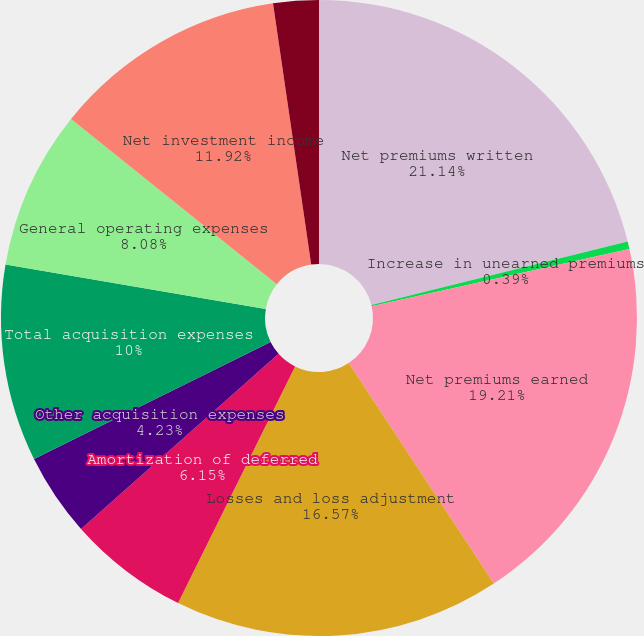Convert chart. <chart><loc_0><loc_0><loc_500><loc_500><pie_chart><fcel>Net premiums written<fcel>Increase in unearned premiums<fcel>Net premiums earned<fcel>Losses and loss adjustment<fcel>Amortization of deferred<fcel>Other acquisition expenses<fcel>Total acquisition expenses<fcel>General operating expenses<fcel>Net investment income<fcel>Pre-tax operating income<nl><fcel>21.13%<fcel>0.39%<fcel>19.21%<fcel>16.57%<fcel>6.15%<fcel>4.23%<fcel>10.0%<fcel>8.08%<fcel>11.92%<fcel>2.31%<nl></chart> 